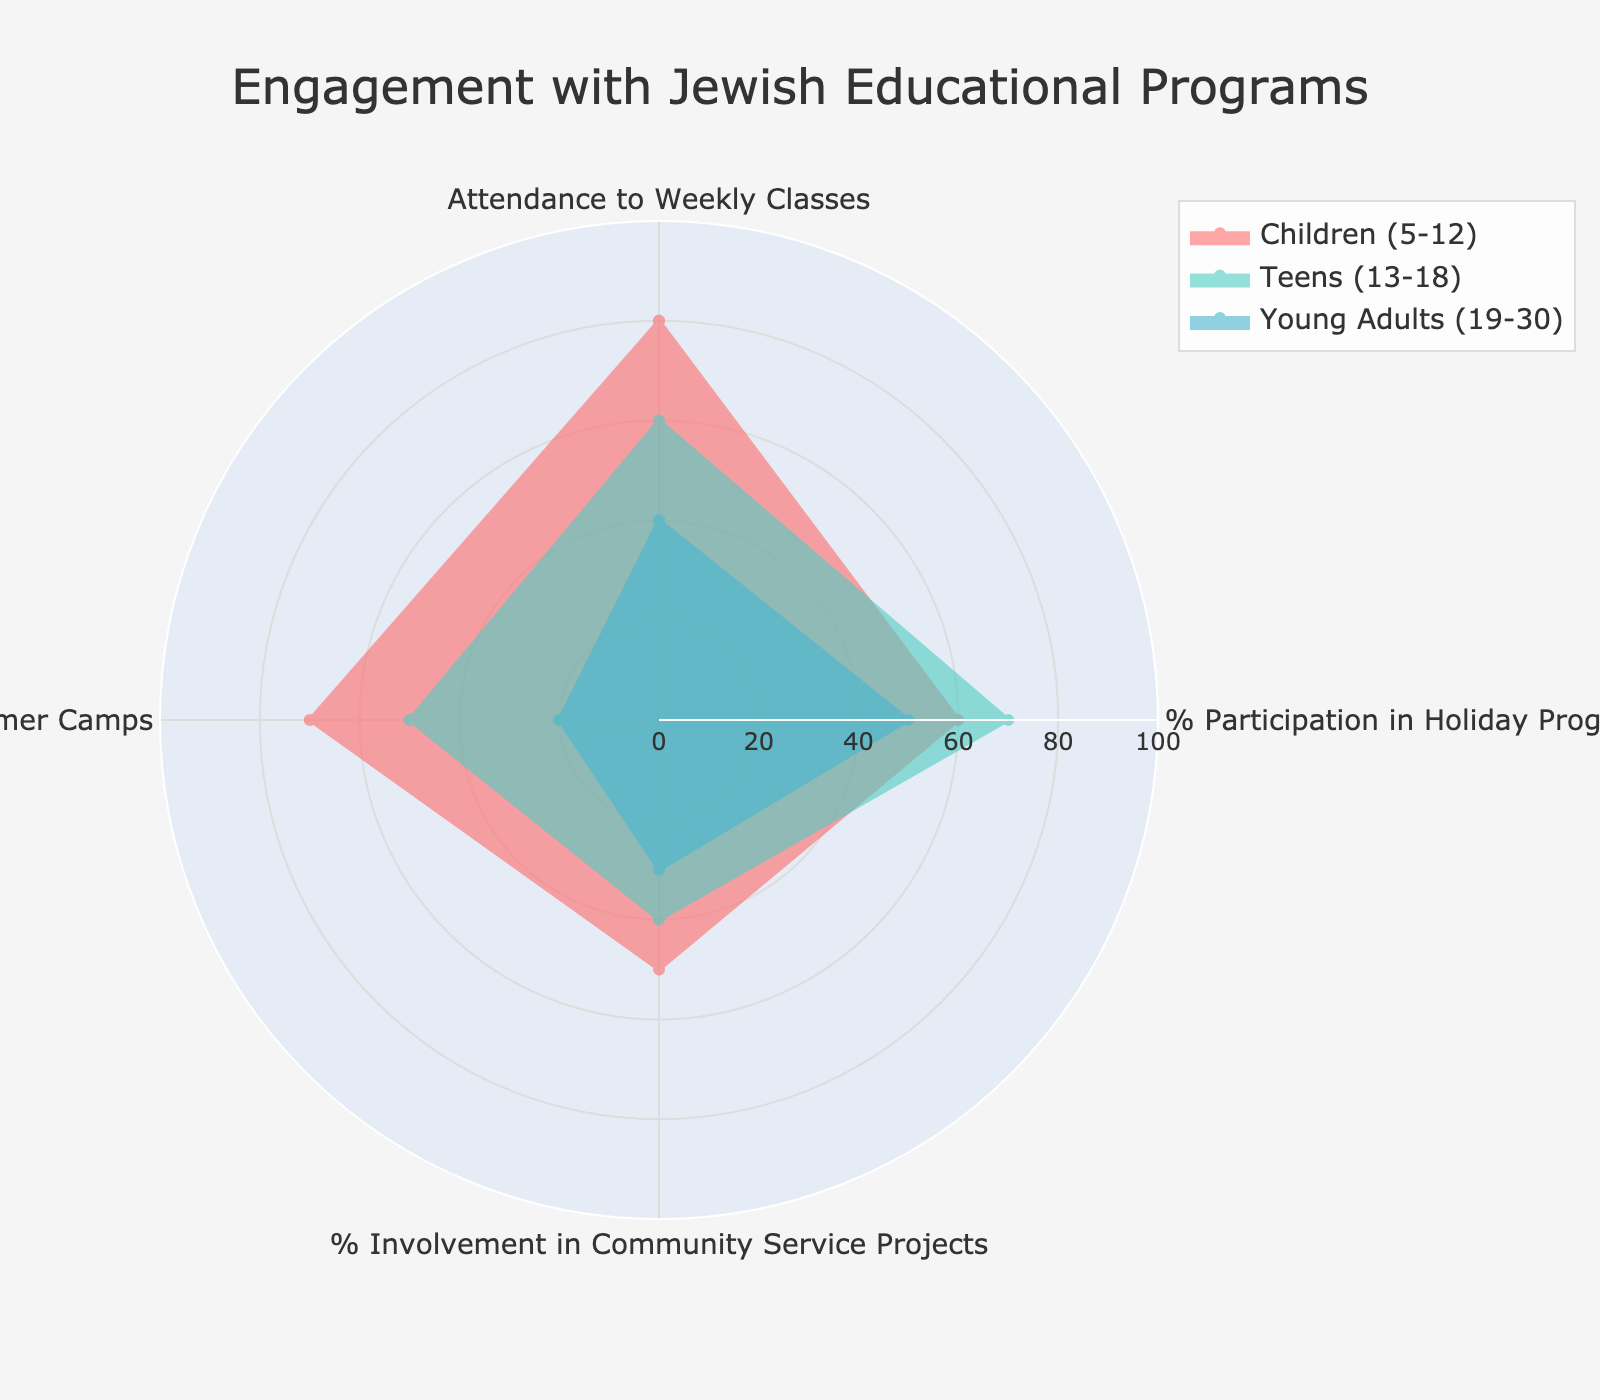what is the highest participation rate in Holiday Programs? To identify the highest participation rate in Holiday Programs, we need to find the largest value under '% Participation in Holiday Programs' across the age groups: Children (5-12) has 60%, Teens (13-18) has 70%, and Young Adults (19-30) has 50%. The highest is 70%.
Answer: 70% What age group has the lowest enrollment in Summer Camps? We compare the enrollment percentages for Summer Camps across all age groups: Children (5-12) has 70%, Teens (13-18) has 50%, and Young Adults (19-30) has 20%. The lowest is Young Adults (19-30) with 20%.
Answer: Young Adults (19-30) Which age group has higher involvement in Community Service Projects, Children (5-12) or Teens (13-18)? Children (5-12) have a 50% involvement rate in Community Service Projects, while Teens (13-18) have a 40% involvement rate. Since 50% is higher than 40%, Children (5-12) have higher involvement.
Answer: Children (5-12) What's the difference in attendance to Weekly Classes between Children (5-12) and Young Adults (19-30)? To find this, we subtract the attendance rate of Young Adults (19-30) from that of Children (5-12). Children (5-12) have 80% attendance, and Young Adults (19-30) have 40% attendance. Thus, the difference is 80% - 40% = 40%.
Answer: 40% What's the average % Participation in Holiday Programs across all age groups? To compute the average participation rate in Holiday Programs, we add the corresponding percentages of all age groups and then divide by the number of groups. Thus, (60% + 70% + 50%) / 3 = 180% / 3 = 60%.
Answer: 60% How do the levels of % Involvement in Community Service Projects compare between Teens (13-18) and Young Adults (19-30)? Teens (13-18) have a 40% involvement rate, while Young Adults (19-30) have a 30% rate. Comparing these values, we see that Teens have a higher involvement rate by 40% - 30% = 10%.
Answer: Teens (13-18) Which age group shows the most balanced engagement in different activities? To determine the most balanced engagement across activities, we look at the variance in participation rates for each age group. Calculating the standard deviations, Teens (13-18) have values ranging from 40% to 70% (SD ~12.9), Children (5-12) from 50% to 80% (SD ~12.2), and Young Adults (19-30) from 20% to 50% (SD ~13.4). Balancing the least variation, Children (5-12) seems most balanced.
Answer: Children (5-12) 